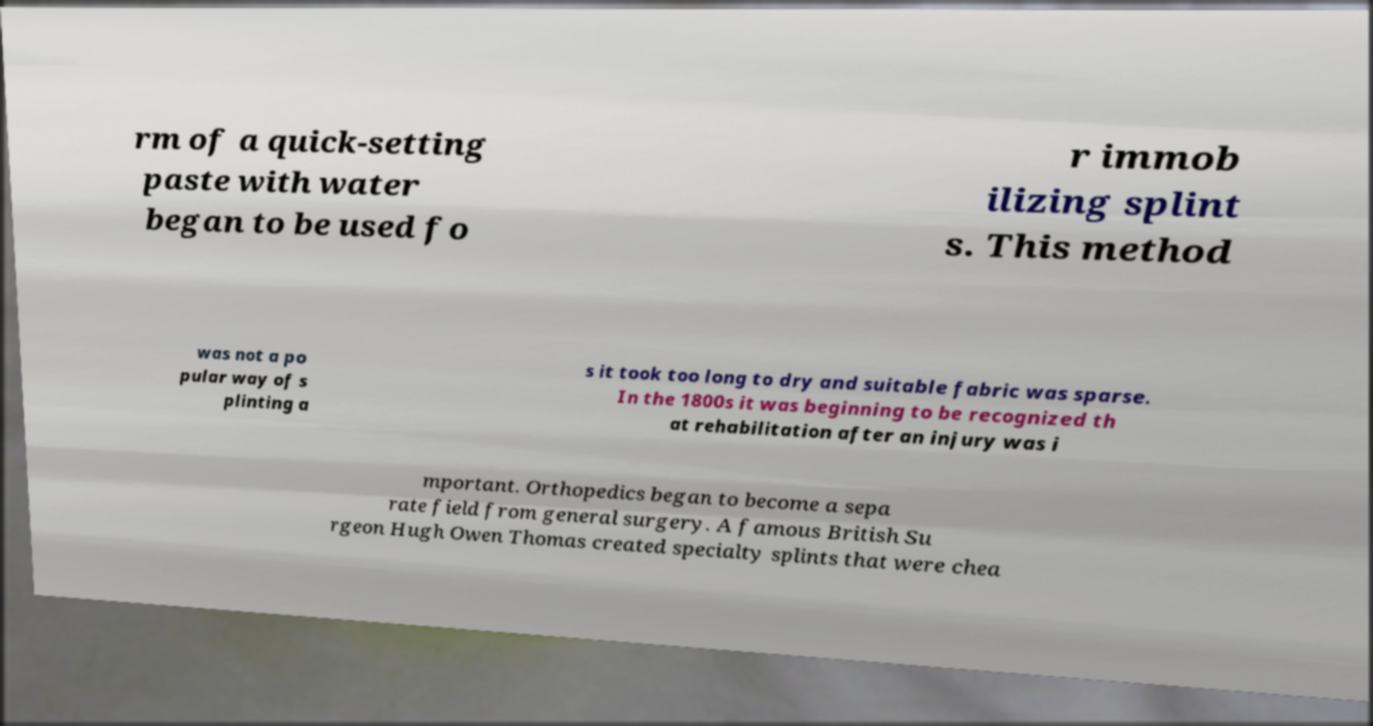Could you extract and type out the text from this image? rm of a quick-setting paste with water began to be used fo r immob ilizing splint s. This method was not a po pular way of s plinting a s it took too long to dry and suitable fabric was sparse. In the 1800s it was beginning to be recognized th at rehabilitation after an injury was i mportant. Orthopedics began to become a sepa rate field from general surgery. A famous British Su rgeon Hugh Owen Thomas created specialty splints that were chea 